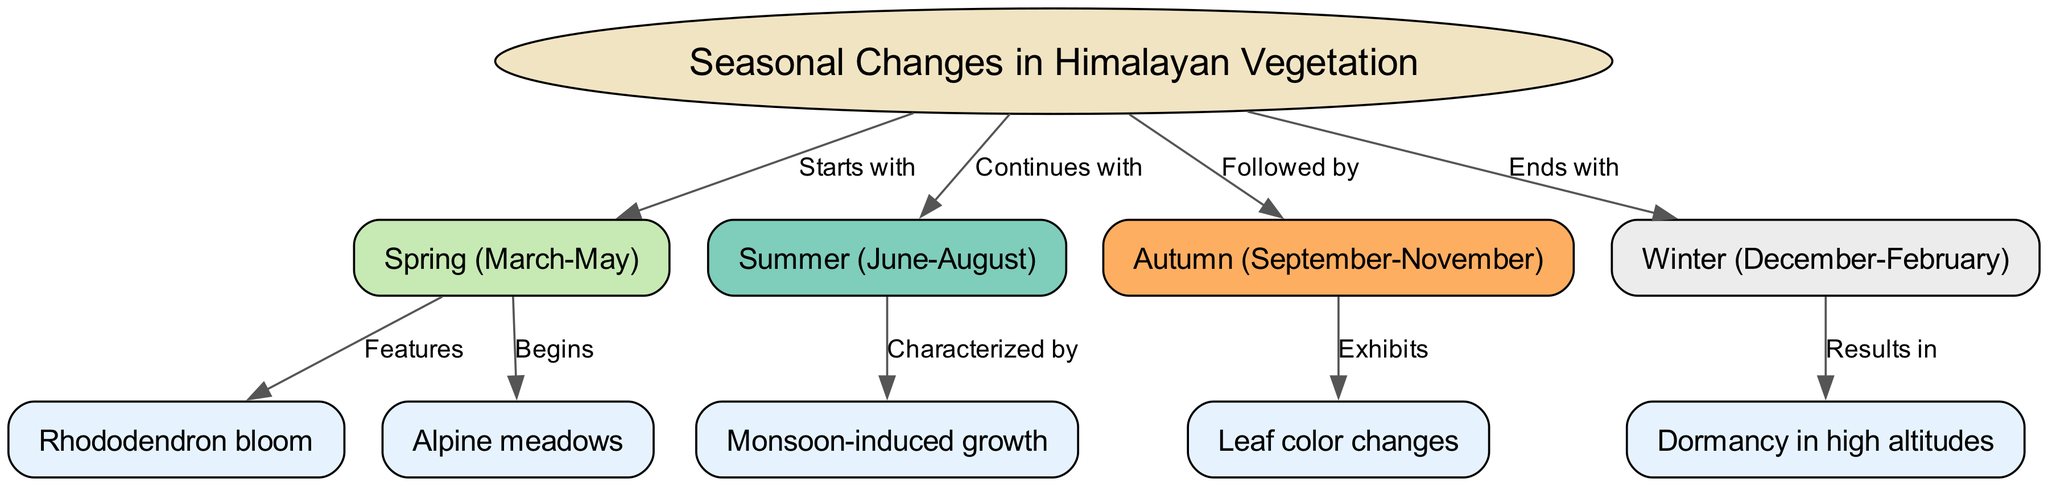What season starts the seasonal changes in Himalayan vegetation? According to the diagram, the first season is Spring, which is labeled on the edge from the main topic to the Spring node.
Answer: Spring (March-May) What features are associated with Spring? The diagram shows an edge leading from Spring to the Rhododendron bloom, indicating that this bloom is a feature of the Spring season.
Answer: Rhododendron bloom How many seasons are depicted in the diagram? The nodes for each season (Spring, Summer, Autumn, and Winter) indicate there are four distinct seasons in the diagram.
Answer: 4 What growth is characterized in Summer? The diagram indicates that the Summer season is characterized by Monsoon-induced growth, which is linked by an edge from Summer to Monsoon-induced growth.
Answer: Monsoon-induced growth Which season exhibits leaf color changes? The edge from Autumn to Leaf color changes shows that this is an exhibit of the Autumn season in the diagram.
Answer: Autumn (September-November) How does Winter affect Himalayan vegetation? The diagram connects Winter to Dormancy in high altitudes, indicating that Winter results in this dormancy effect on vegetation.
Answer: Dormancy in high altitudes What comes after Spring in the seasonal changes? The diagram shows an edge indicating that the seasonal changes continue from Spring to Summer, making Summer the next season.
Answer: Summer (June-August) Which season is characterized by Alpine meadows? The edge from Spring indicates that Alpine meadows begin during the Spring season, showing its connection to the start of vegetation changes.
Answer: Spring (March-May) 